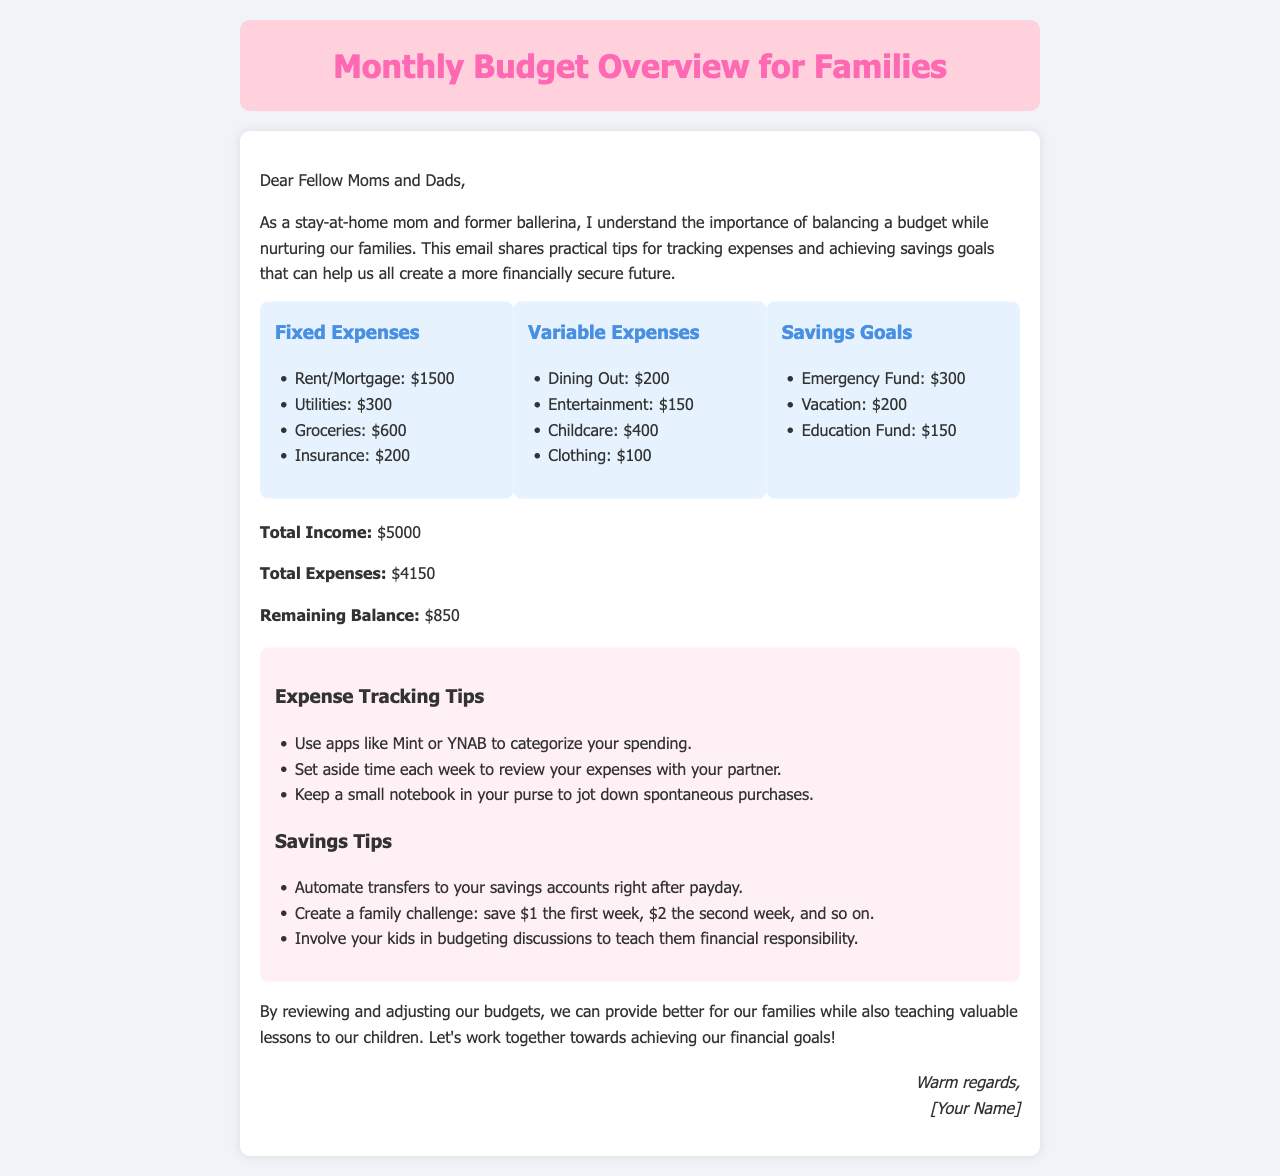What are the total fixed expenses? The fixed expenses are listed as Rent/Mortgage, Utilities, Groceries, and Insurance. Adding these together gives a total of $1500 + $300 + $600 + $200 = $2600.
Answer: $2600 What is the budget for dining out? The document specifies the budget allocated for dining out under variable expenses.
Answer: $200 How much is allocated for the emergency fund? The emergency fund is categorized under savings goals in the document.
Answer: $300 What is the total income stated? The total income is clearly mentioned in the document.
Answer: $5000 What is the remaining balance after expenses? The remaining balance is calculated by subtracting total expenses from total income. The document states that the remaining balance is $5000 - $4150.
Answer: $850 What expenses are tracked weekly? The document suggests reviewing expenses with your partner each week, though it does not provide specific categories that need to be reviewed weekly.
Answer: Expenses How can families involve children in budgeting? The document suggests involving children in discussions about budgeting to teach them financial responsibility.
Answer: Budgeting discussions What is one savings tip mentioned? One of the savings tips involves automating transfers to savings accounts right after payday, as stated in the tips section.
Answer: Automate transfers What color is used for the header background? The header background color is mentioned in the style section of the document.
Answer: Pink 